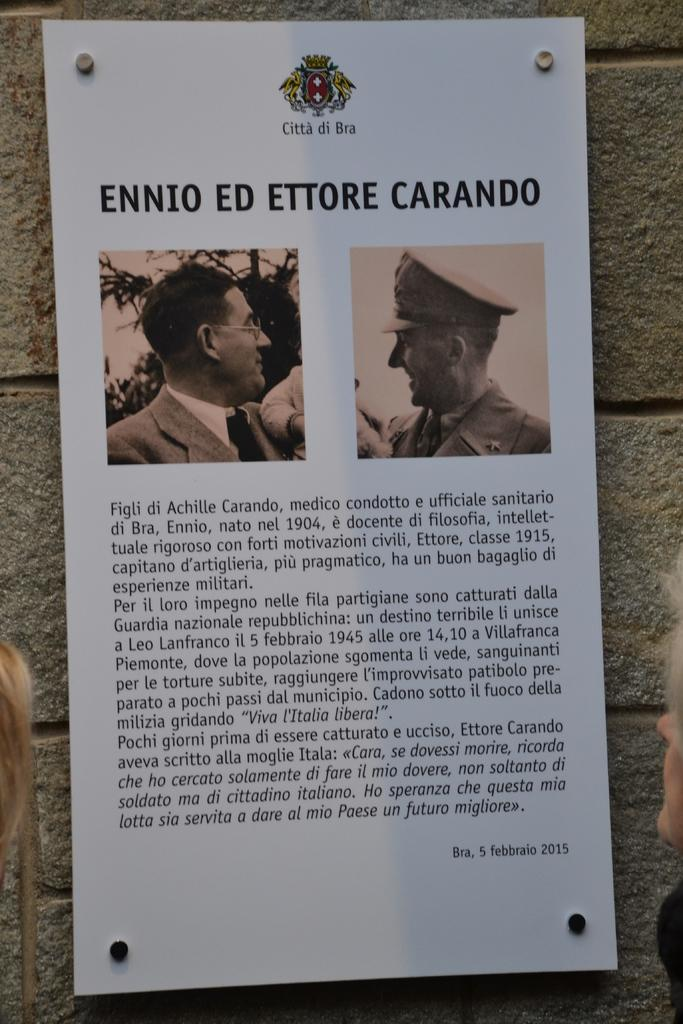What is attached to the wall in the image? There is a paper attached to the wall in the image. What is depicted on the paper? There is a person's image on the paper. What else can be found on the paper besides the image? There is text on the paper. What type of throat lozenges are in the bag next to the person in the image? There is no bag or throat lozenges present in the image. What industry is the person in the image associated with? The image does not provide any information about the person's industry or profession. 